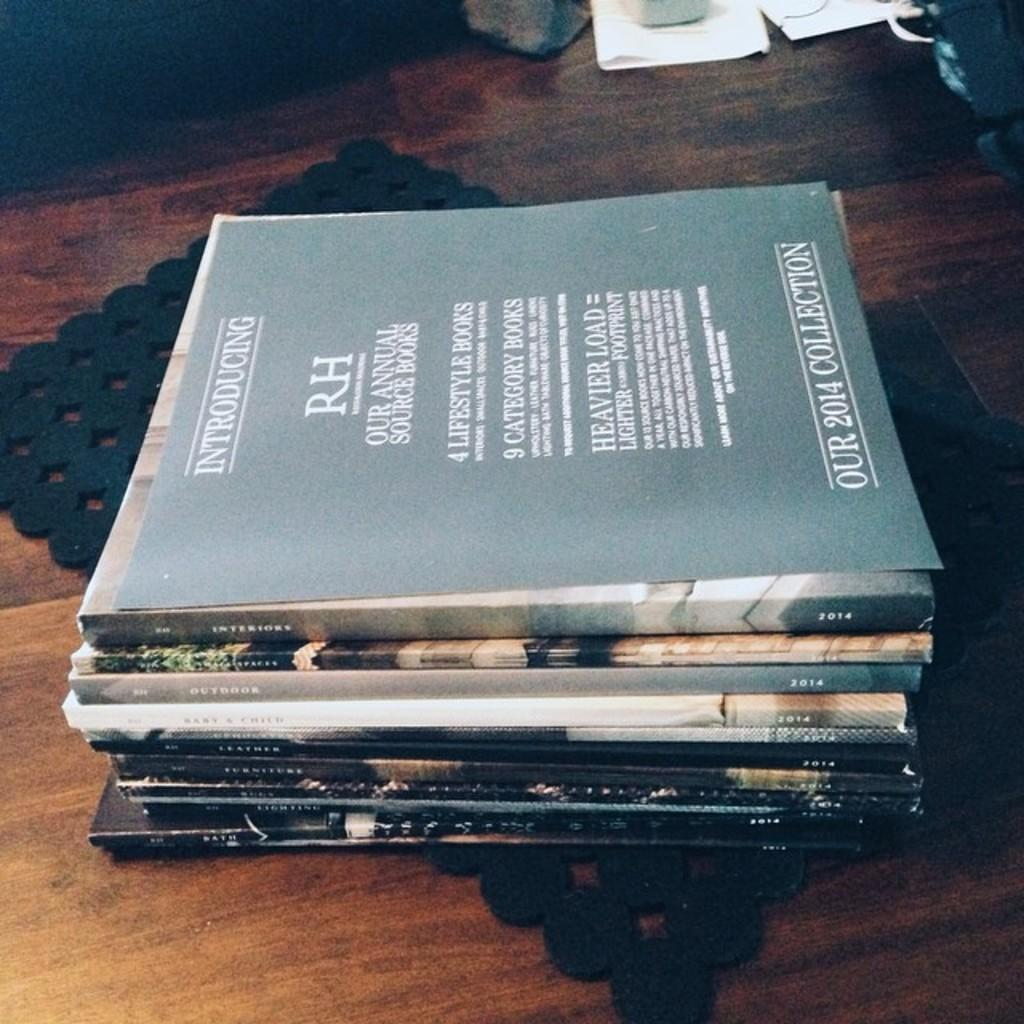<image>
Create a compact narrative representing the image presented. A collection of books that all appear to be from the year 2014. 